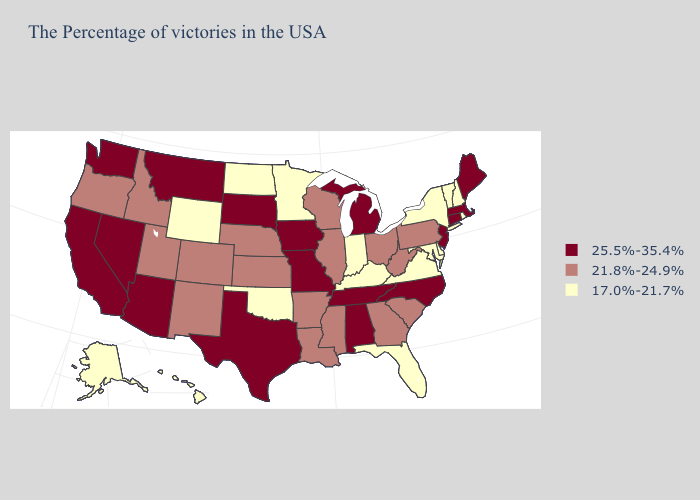Among the states that border Montana , does North Dakota have the lowest value?
Be succinct. Yes. Name the states that have a value in the range 17.0%-21.7%?
Concise answer only. Rhode Island, New Hampshire, Vermont, New York, Delaware, Maryland, Virginia, Florida, Kentucky, Indiana, Minnesota, Oklahoma, North Dakota, Wyoming, Alaska, Hawaii. Does Arizona have the same value as Wyoming?
Answer briefly. No. Among the states that border Pennsylvania , which have the highest value?
Give a very brief answer. New Jersey. Does Rhode Island have a lower value than South Carolina?
Be succinct. Yes. Name the states that have a value in the range 21.8%-24.9%?
Concise answer only. Pennsylvania, South Carolina, West Virginia, Ohio, Georgia, Wisconsin, Illinois, Mississippi, Louisiana, Arkansas, Kansas, Nebraska, Colorado, New Mexico, Utah, Idaho, Oregon. Does California have the same value as Texas?
Write a very short answer. Yes. Which states hav the highest value in the MidWest?
Short answer required. Michigan, Missouri, Iowa, South Dakota. Does the first symbol in the legend represent the smallest category?
Answer briefly. No. Name the states that have a value in the range 17.0%-21.7%?
Concise answer only. Rhode Island, New Hampshire, Vermont, New York, Delaware, Maryland, Virginia, Florida, Kentucky, Indiana, Minnesota, Oklahoma, North Dakota, Wyoming, Alaska, Hawaii. Does Hawaii have the highest value in the USA?
Concise answer only. No. Name the states that have a value in the range 21.8%-24.9%?
Keep it brief. Pennsylvania, South Carolina, West Virginia, Ohio, Georgia, Wisconsin, Illinois, Mississippi, Louisiana, Arkansas, Kansas, Nebraska, Colorado, New Mexico, Utah, Idaho, Oregon. Which states hav the highest value in the South?
Write a very short answer. North Carolina, Alabama, Tennessee, Texas. Which states have the highest value in the USA?
Give a very brief answer. Maine, Massachusetts, Connecticut, New Jersey, North Carolina, Michigan, Alabama, Tennessee, Missouri, Iowa, Texas, South Dakota, Montana, Arizona, Nevada, California, Washington. What is the value of Maine?
Give a very brief answer. 25.5%-35.4%. 